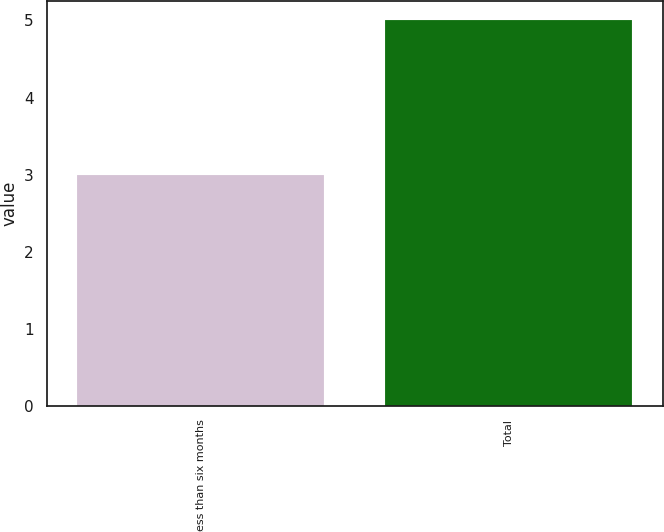Convert chart. <chart><loc_0><loc_0><loc_500><loc_500><bar_chart><fcel>Less than six months<fcel>Total<nl><fcel>3<fcel>5<nl></chart> 